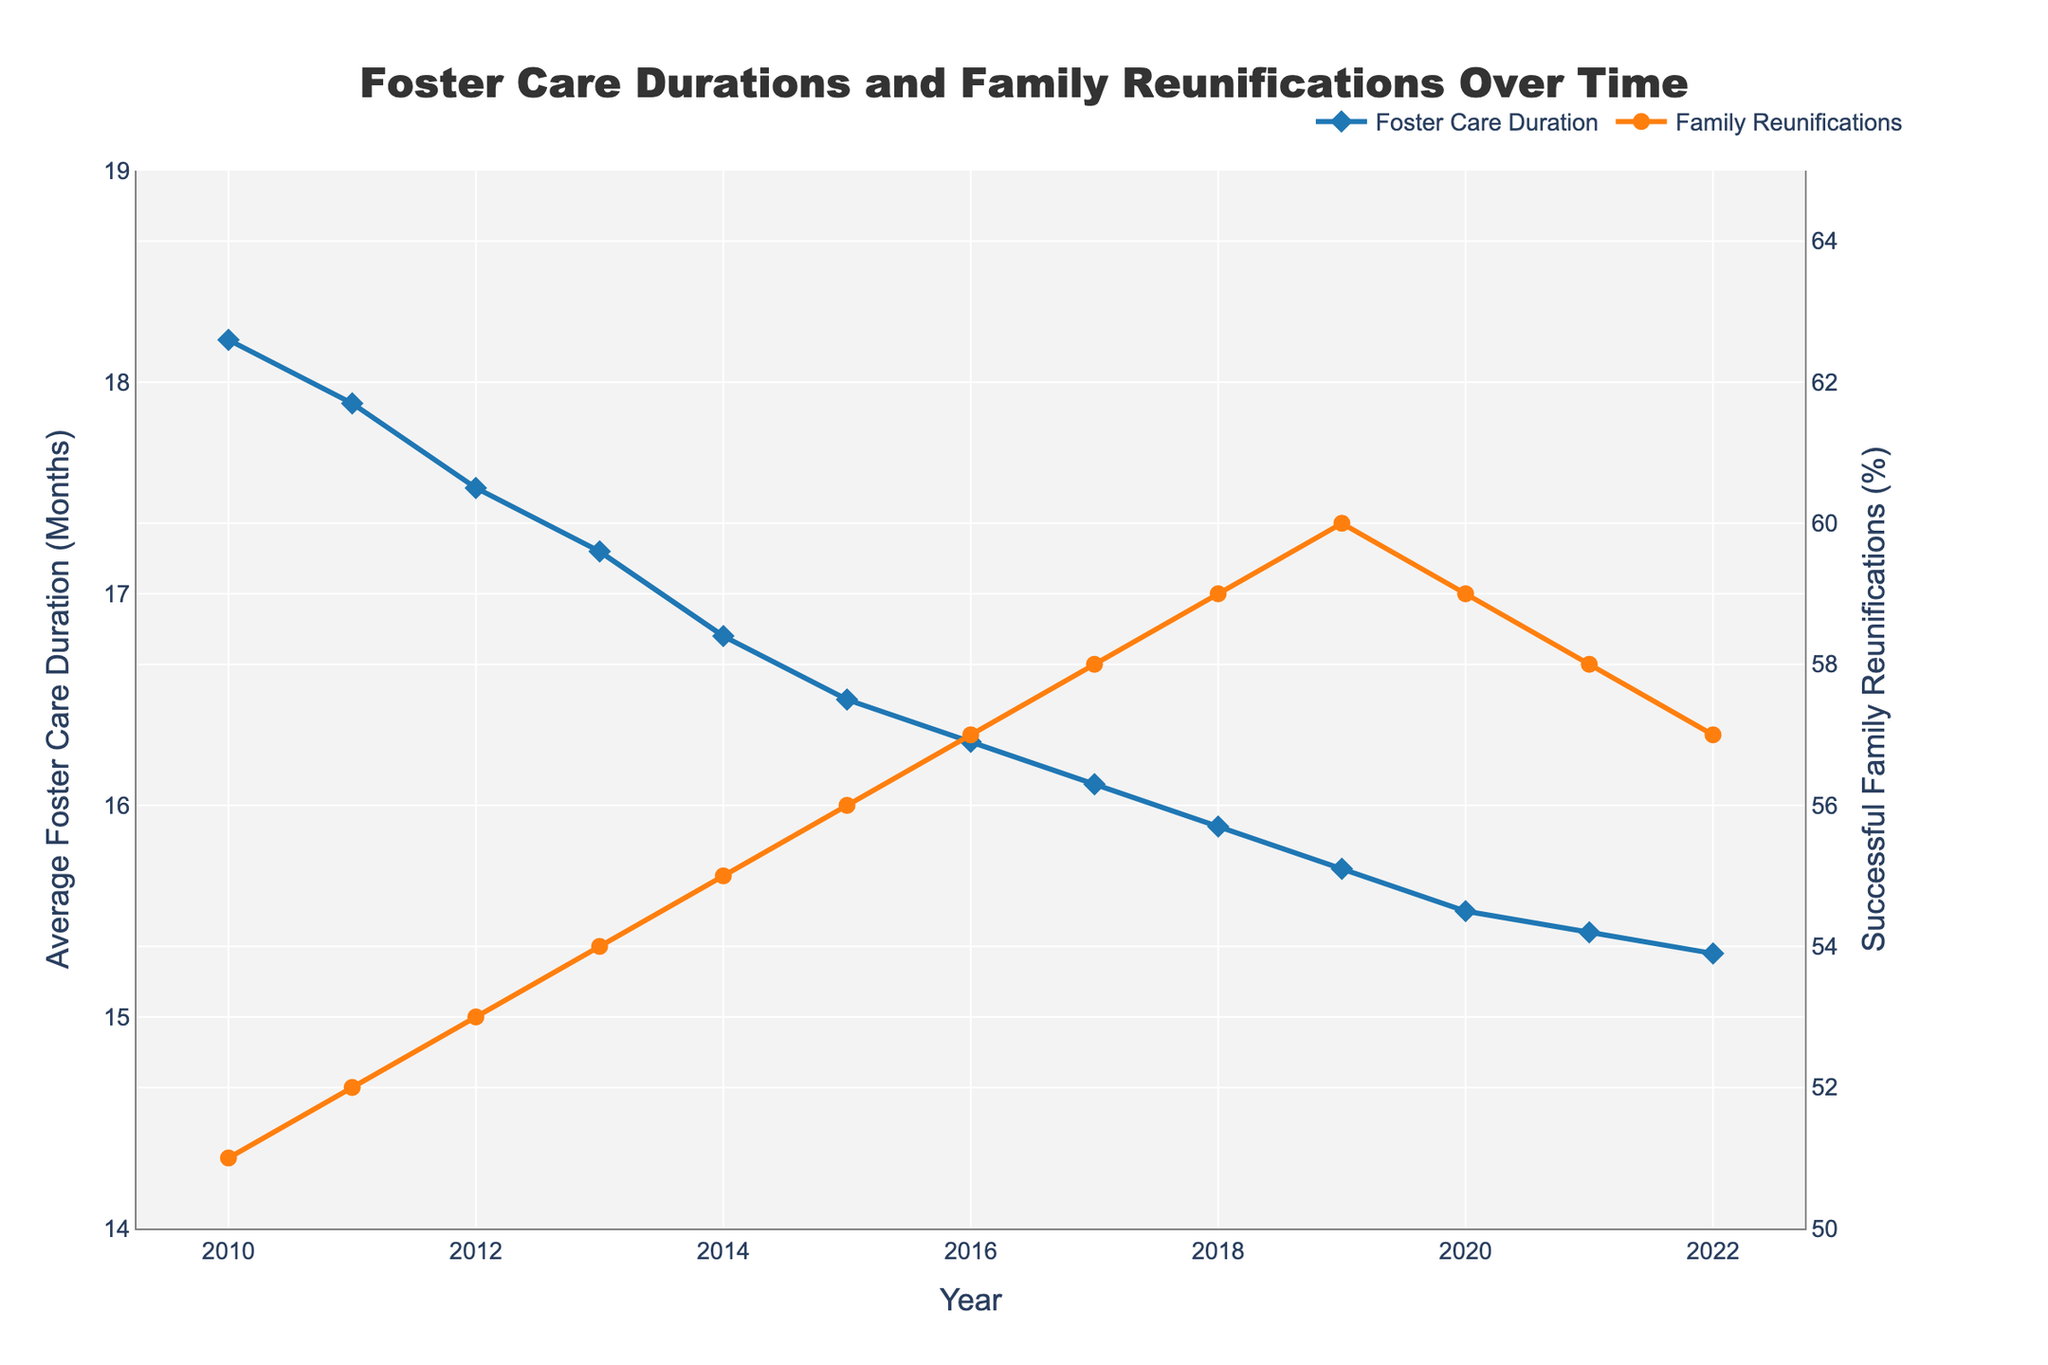What's the overall trend in average foster care duration from 2010 to 2022? The trend can be observed by examining the line representing "Average Foster Care Duration (Months)" from 2010 to 2022 on the chart. It starts at 18.2 months in 2010 and decreases steadily over the years to 15.3 months in 2022.
Answer: Decreasing When was the highest percentage of successful family reunifications, and what was that percentage? By looking at the line representing "Successful Family Reunifications (%)", we see the peak is in 2019 with a percentage of 60%.
Answer: 2019, 60% How much did the average foster care duration decrease from 2010 to 2022? The duration in 2010 was 18.2 months and in 2022 it was 15.3 months. The decrease is calculated as 18.2 - 15.3.
Answer: 2.9 months Compare the trends in foster care duration and family reunifications between 2016 and 2019. From 2016 to 2019, the "Average Foster Care Duration (Months)" decreased from 16.3 to 15.7 months, and "Successful Family Reunifications (%)" increased from 57% to 60%. This indicates a simultaneous improvement in both metrics.
Answer: Decrease in duration, increase in reunifications Was there any year where the percentage of successful family reunifications decreased compared to the previous year? By examining the "Successful Family Reunifications (%)" line, we see a decrease between 2019 (60%) and 2020 (59%), 2020 (59%) and 2021 (58%), and between 2021 (58%) and 2022 (57%).
Answer: Yes, in 2020, 2021, and 2022 In which year did the average foster care duration first fall below 16 months? By referring to the line chart, we observe that in 2017, the average foster care duration was 16.1 months and in 2018, it reached 15.9 months, which is the first instance below 16.
Answer: 2018 What is the relationship between the color of the lines and the metrics they represent? On the chart, the line for "Average Foster Care Duration (Months)" is blue, while the line for "Successful Family Reunifications (%)" is orange. These color codes help distinguish between the two metrics visually.
Answer: Blue for duration, orange for reunifications What is the average percentage of successful family reunifications over the period 2010 to 2022? Adding up the percentages from 2010 to 2022: (51 + 52 + 53 + 54 + 55 + 56 + 57 + 58 + 59 + 60 + 59 + 58 + 57) gives us 689. Dividing by the number of years (13): 689 / 13.
Answer: 53٪ How many years show a decreasing percentage of successful family reunifications? Observing the chart, there are decreases in three years: from 2019 to 2020, 2020 to 2021, and 2021 to 2022.
Answer: 3 years 